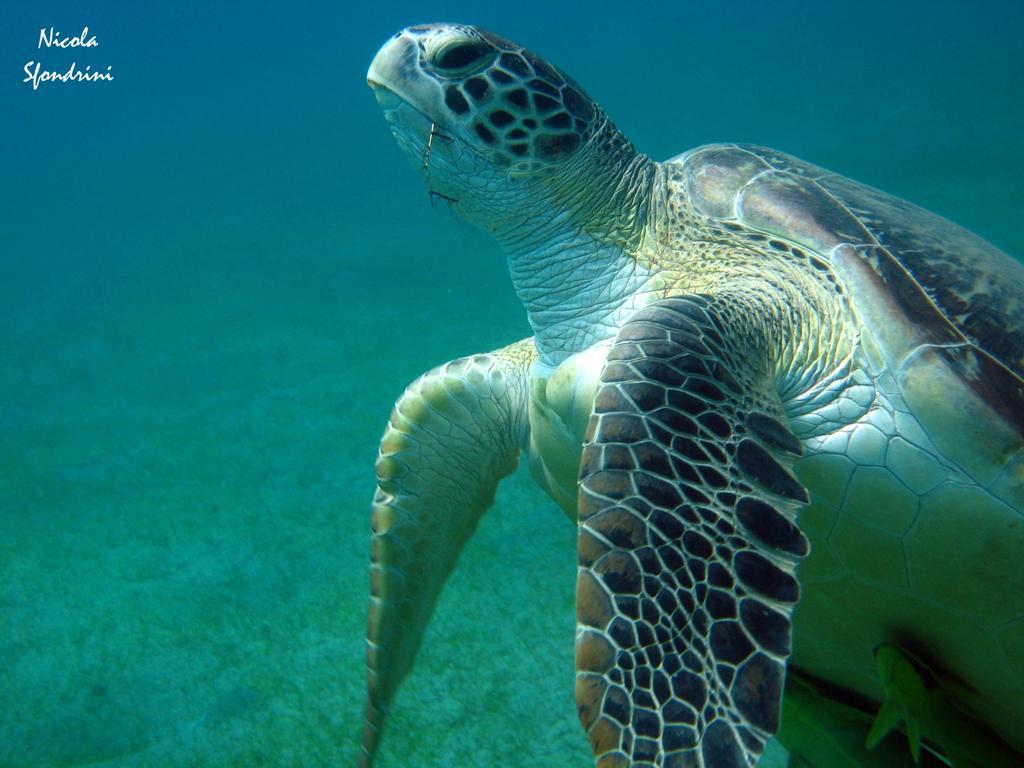Can you describe this image briefly? In this image there is a turtle under the water. 